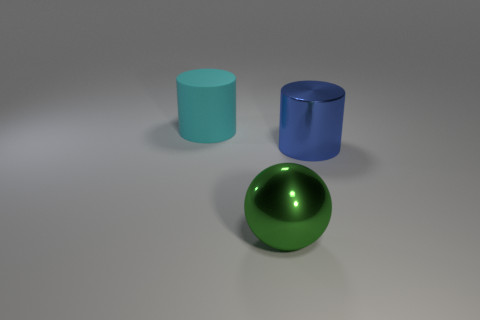There is a large cylinder that is to the left of the green metallic object; does it have the same color as the shiny object in front of the large blue thing?
Your response must be concise. No. There is a shiny cylinder; are there any green objects right of it?
Your response must be concise. No. There is a big thing that is both in front of the cyan cylinder and behind the green object; what is its material?
Give a very brief answer. Metal. Do the cylinder on the left side of the big blue shiny cylinder and the blue cylinder have the same material?
Ensure brevity in your answer.  No. What material is the ball?
Offer a very short reply. Metal. What is the size of the cylinder that is in front of the big matte thing?
Offer a very short reply. Large. Is there any other thing that is the same color as the metal sphere?
Offer a terse response. No. There is a object that is on the left side of the metal thing in front of the big blue shiny thing; is there a large green metal ball to the left of it?
Your answer should be very brief. No. Do the large cylinder that is on the right side of the cyan rubber thing and the matte cylinder have the same color?
Your answer should be very brief. No. What number of balls are either big blue objects or large shiny objects?
Your response must be concise. 1. 